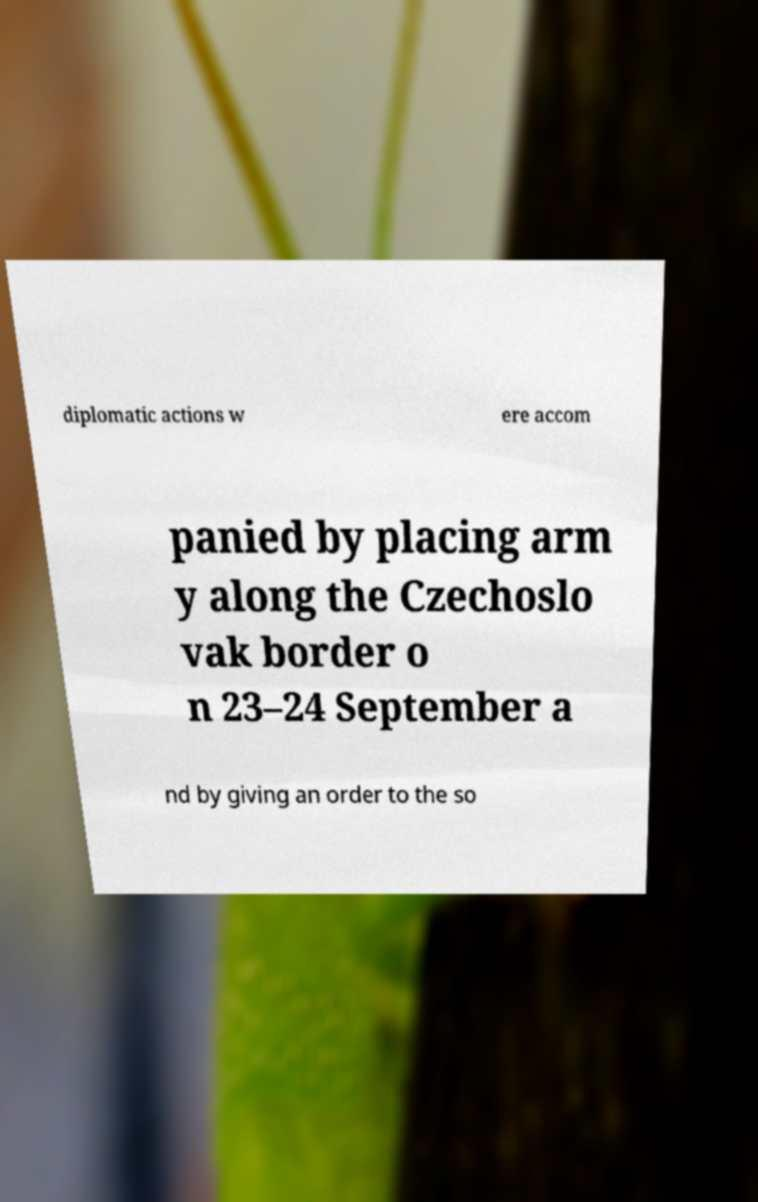I need the written content from this picture converted into text. Can you do that? diplomatic actions w ere accom panied by placing arm y along the Czechoslo vak border o n 23–24 September a nd by giving an order to the so 